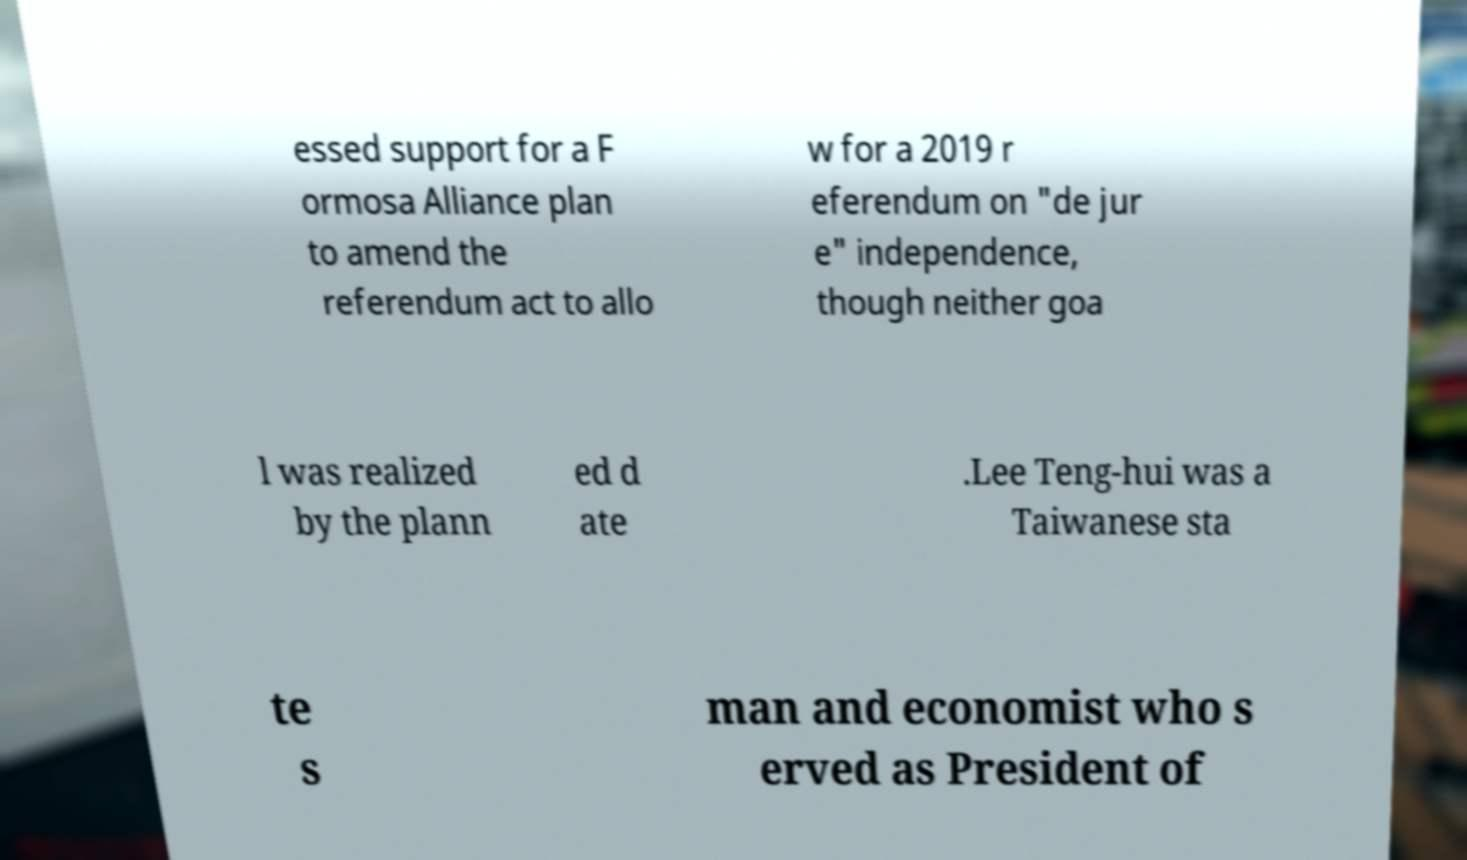There's text embedded in this image that I need extracted. Can you transcribe it verbatim? essed support for a F ormosa Alliance plan to amend the referendum act to allo w for a 2019 r eferendum on "de jur e" independence, though neither goa l was realized by the plann ed d ate .Lee Teng-hui was a Taiwanese sta te s man and economist who s erved as President of 